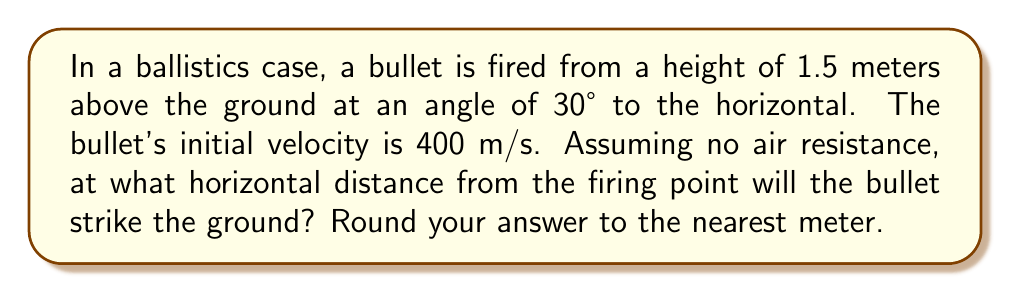Help me with this question. Let's approach this step-by-step using trigonometry and projectile motion equations:

1) First, we need to break down the initial velocity into its horizontal and vertical components:

   $v_x = v \cos\theta = 400 \cos 30° = 400 \cdot \frac{\sqrt{3}}{2} = 200\sqrt{3}$ m/s
   $v_y = v \sin\theta = 400 \sin 30° = 400 \cdot \frac{1}{2} = 200$ m/s

2) The time of flight can be calculated using the vertical motion equation:

   $y = y_0 + v_y t - \frac{1}{2}gt^2$

   Where $y = 0$ (ground level), $y_0 = 1.5$ m (initial height), $v_y = 200$ m/s, and $g = 9.8$ m/s².

3) Substituting these values:

   $0 = 1.5 + 200t - 4.9t^2$

4) Rearranging:

   $4.9t^2 - 200t - 1.5 = 0$

5) This is a quadratic equation. We can solve it using the quadratic formula:

   $t = \frac{-b \pm \sqrt{b^2 - 4ac}}{2a}$

   Where $a = 4.9$, $b = -200$, and $c = -1.5$

6) Solving:

   $t = \frac{200 \pm \sqrt{40000 + 29.4}}{9.8} = \frac{200 \pm 200.0735}{9.8}$

7) We take the positive solution:

   $t = \frac{400.0735}{9.8} \approx 40.82$ seconds

8) Now we can calculate the horizontal distance using $x = v_x t$:

   $x = 200\sqrt{3} \cdot 40.82 \approx 14149.7$ meters

9) Rounding to the nearest meter:

   $x \approx 14150$ meters
Answer: 14150 meters 